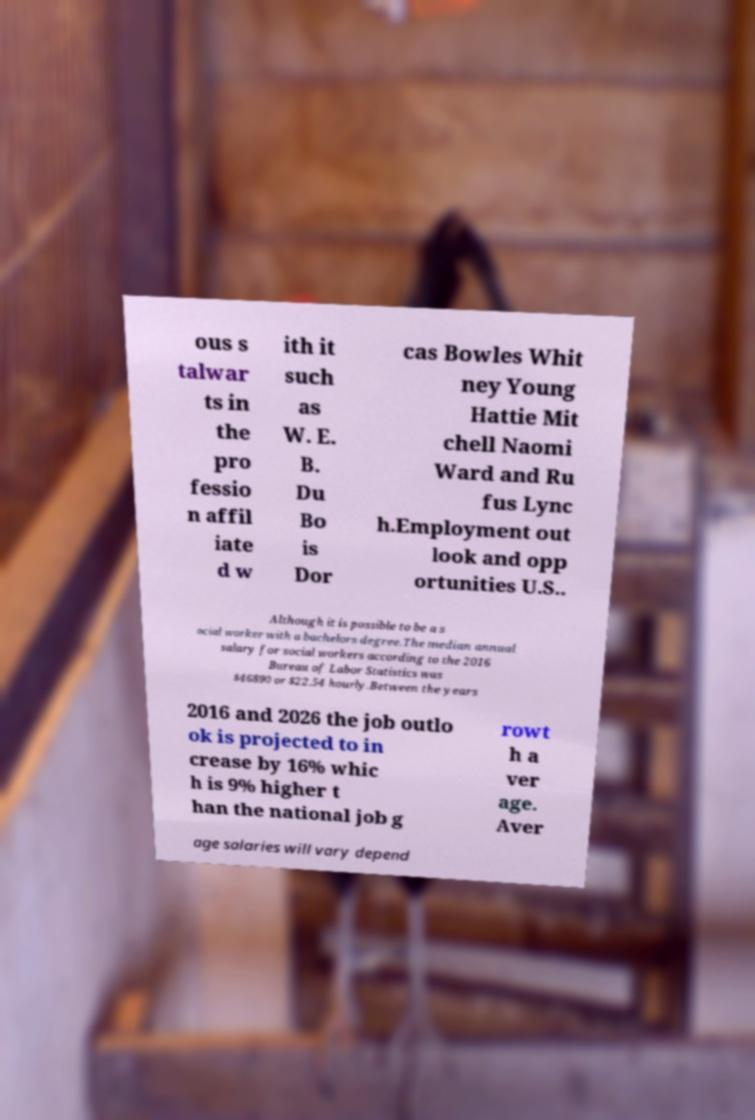I need the written content from this picture converted into text. Can you do that? ous s talwar ts in the pro fessio n affil iate d w ith it such as W. E. B. Du Bo is Dor cas Bowles Whit ney Young Hattie Mit chell Naomi Ward and Ru fus Lync h.Employment out look and opp ortunities U.S.. Although it is possible to be a s ocial worker with a bachelors degree.The median annual salary for social workers according to the 2016 Bureau of Labor Statistics was $46890 or $22.54 hourly.Between the years 2016 and 2026 the job outlo ok is projected to in crease by 16% whic h is 9% higher t han the national job g rowt h a ver age. Aver age salaries will vary depend 